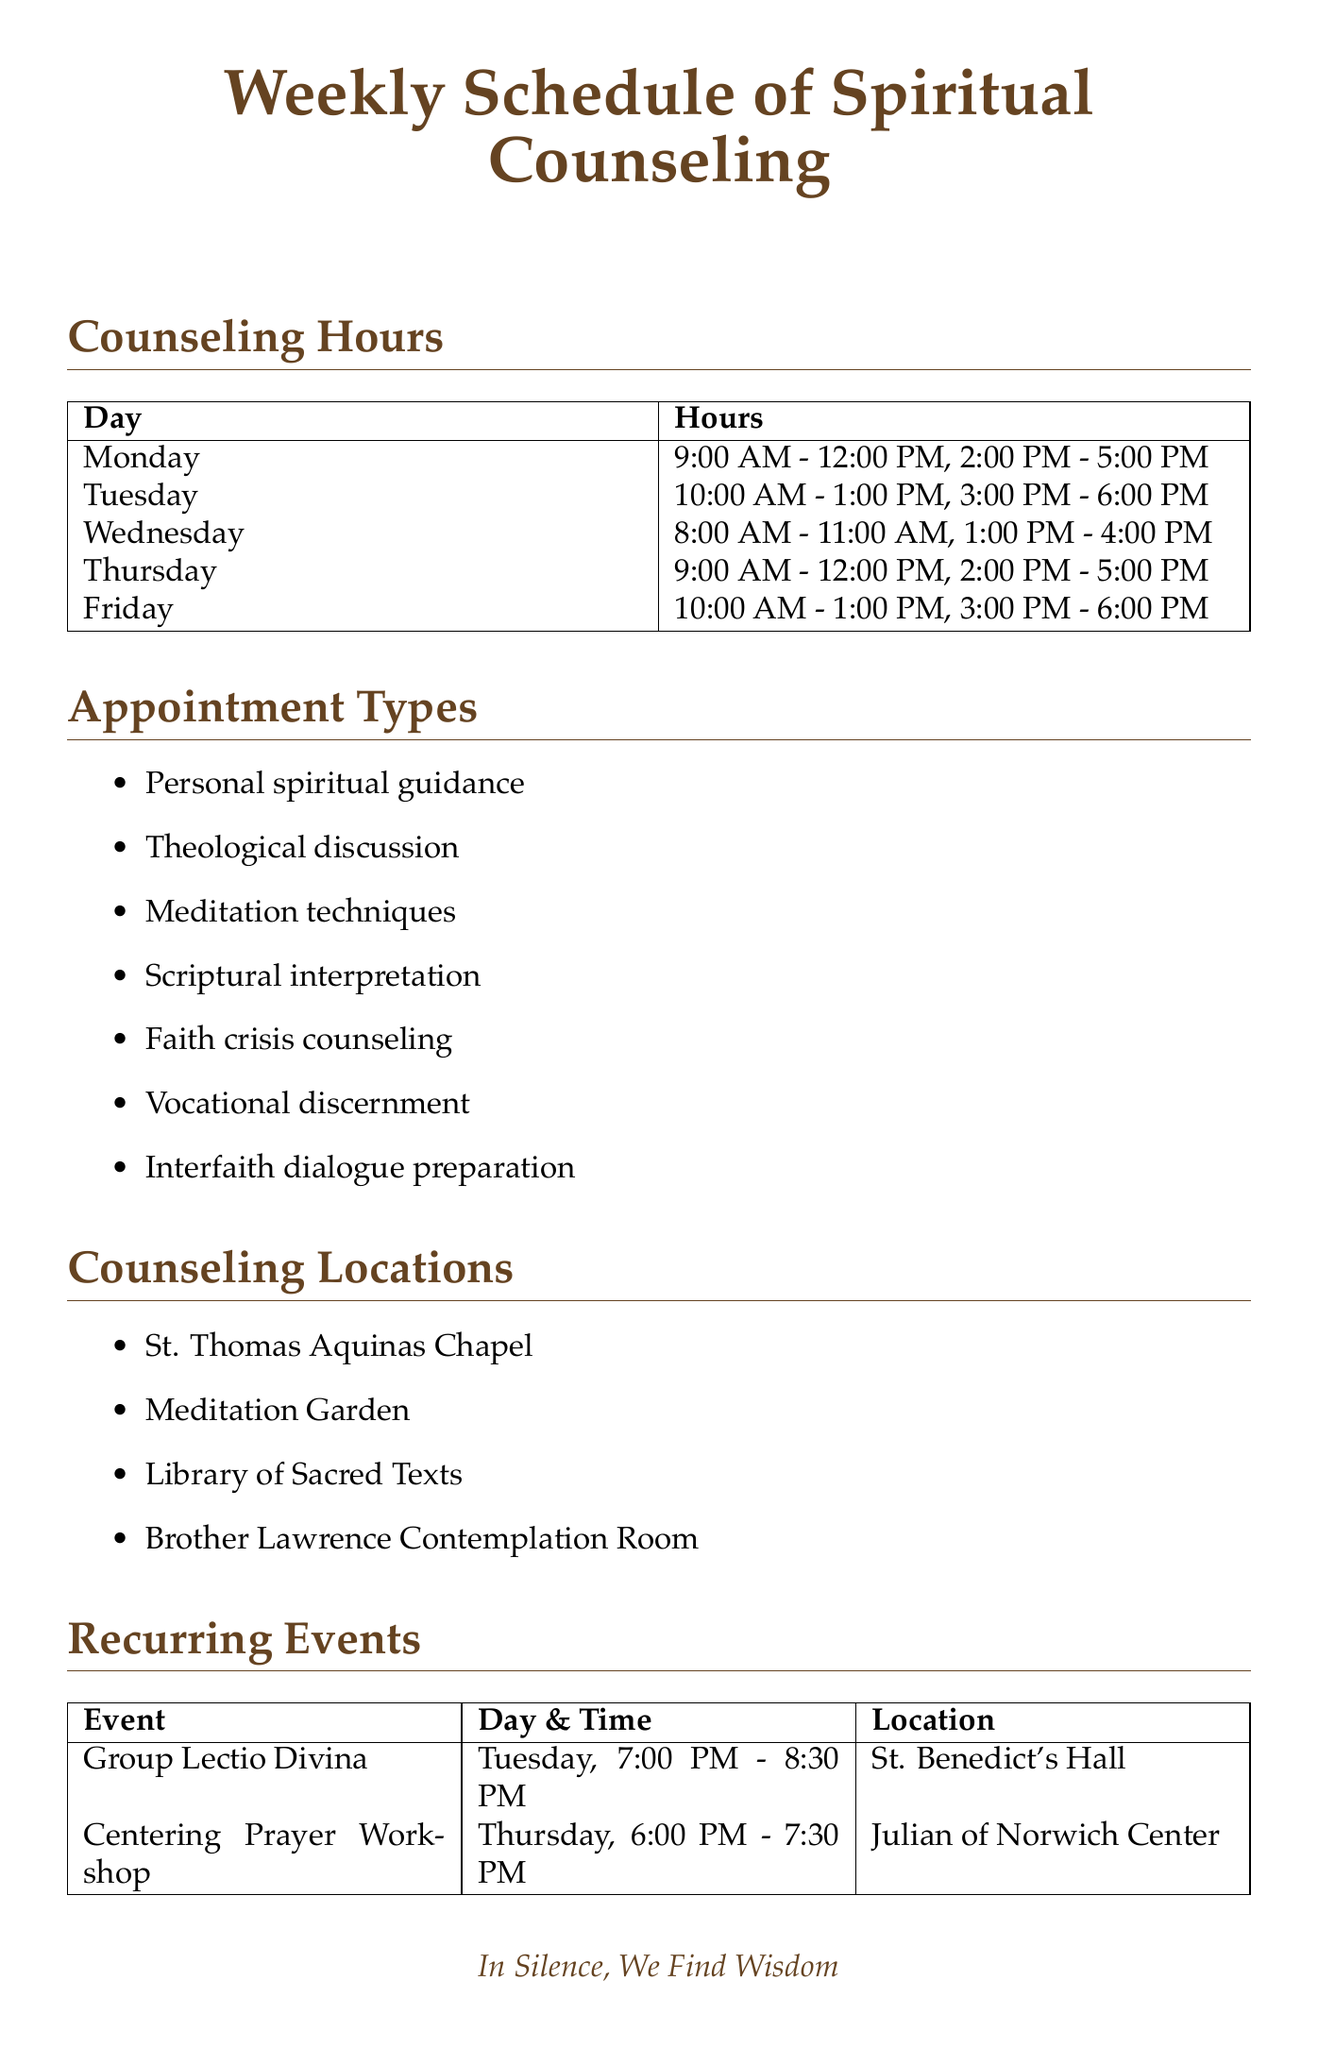What are the counseling hours on Friday? The document lists the hours for each day, showing that Friday has two time slots: 10:00 AM - 1:00 PM and 3:00 PM - 6:00 PM.
Answer: 10:00 AM - 1:00 PM, 3:00 PM - 6:00 PM What location is used for the Desert Day Retreat? The document states the location for the Desert Day Retreat, which is "Hermitage Grounds."
Answer: Hermitage Grounds How many types of counseling appointments are there? The document lists a total of seven different types of counseling appointments for the students.
Answer: 7 On which day does the Taizé Prayer Service occur? According to the document, the Taizé Prayer Service is held on the first Friday of each month, which identifies it by a day of the week.
Answer: Friday What is the frequency of the Group Lectio Divina? The document specifies that Group Lectio Divina takes place every Tuesday evening at the same time.
Answer: Weekly What is one of the spiritual practices mentioned? The document provides a list of spiritual practices, including "Centering Prayer" as one of the options.
Answer: Centering Prayer Which student group meets specified in the document? The document mentions "Graduate Theological Union" as one of the explicitly listed student groups.
Answer: Graduate Theological Union What is the time for the Centering Prayer Workshop? The document provides the time as part of the recurring events for the Centering Prayer Workshop, which can be found on Thursday.
Answer: 6:00 PM - 7:30 PM 